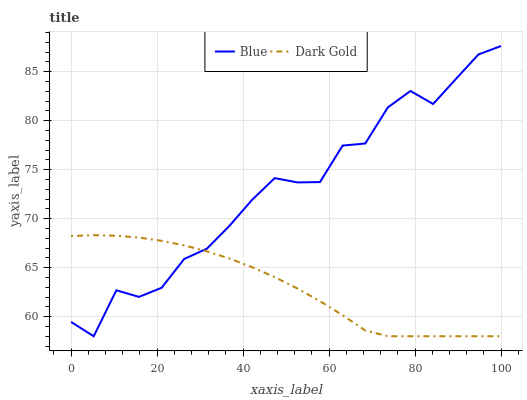Does Dark Gold have the minimum area under the curve?
Answer yes or no. Yes. Does Blue have the maximum area under the curve?
Answer yes or no. Yes. Does Dark Gold have the maximum area under the curve?
Answer yes or no. No. Is Dark Gold the smoothest?
Answer yes or no. Yes. Is Blue the roughest?
Answer yes or no. Yes. Is Dark Gold the roughest?
Answer yes or no. No. Does Dark Gold have the highest value?
Answer yes or no. No. 